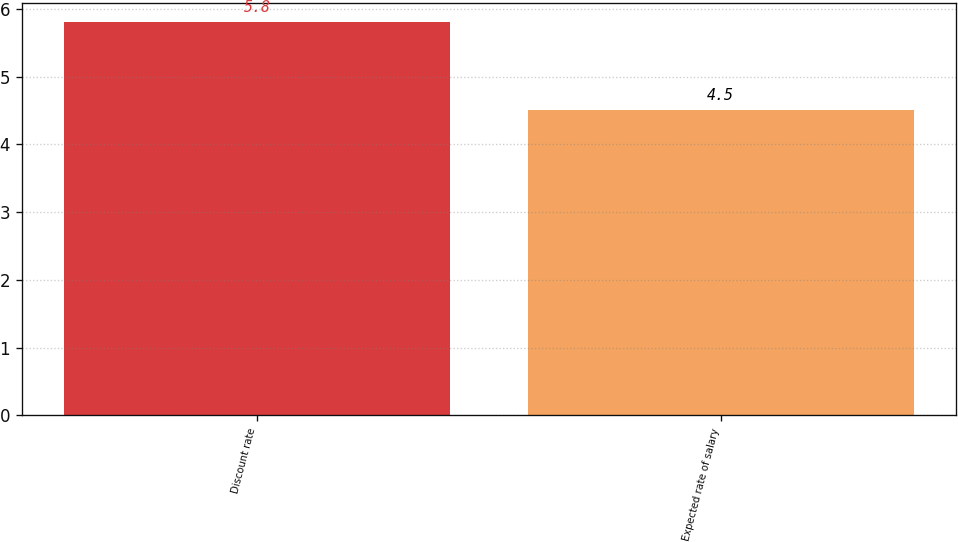<chart> <loc_0><loc_0><loc_500><loc_500><bar_chart><fcel>Discount rate<fcel>Expected rate of salary<nl><fcel>5.8<fcel>4.5<nl></chart> 